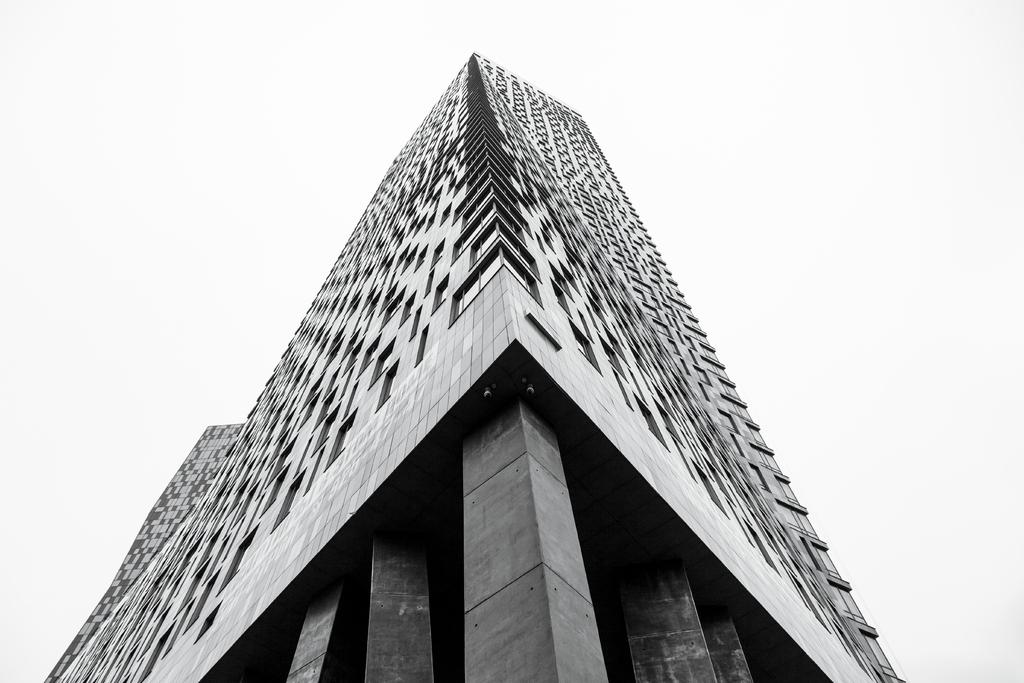What type of structure is visible in the image? There is a building in the image. What architectural feature can be seen on the building? The building has pillars. What color is the background of the image? The background of the image is white. What color is the learning material in the image? There is no learning material present in the image, so it cannot be determined what color it might be. 